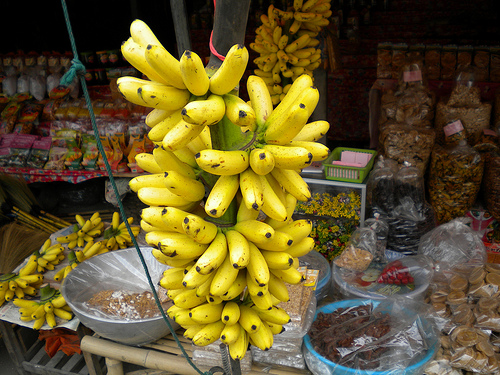Please provide a short description for this region: [0.85, 0.65, 0.99, 0.87]. This region captures bags of cookies, likely homemade, adding a touch of sweetness and hominess to the local market's diverse offerings. 